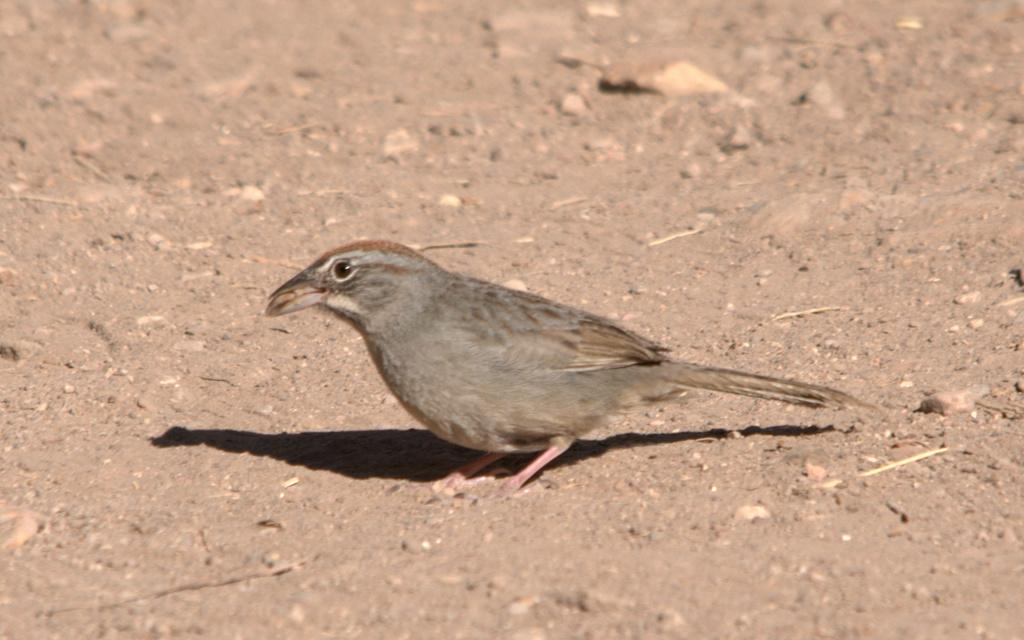What type of animal can be seen in the image? There is a bird in the image. Where is the bird located in the image? The bird is standing on the land. What does the bird's brain smell like in the image? There is no information about the bird's brain or its smell in the image. 